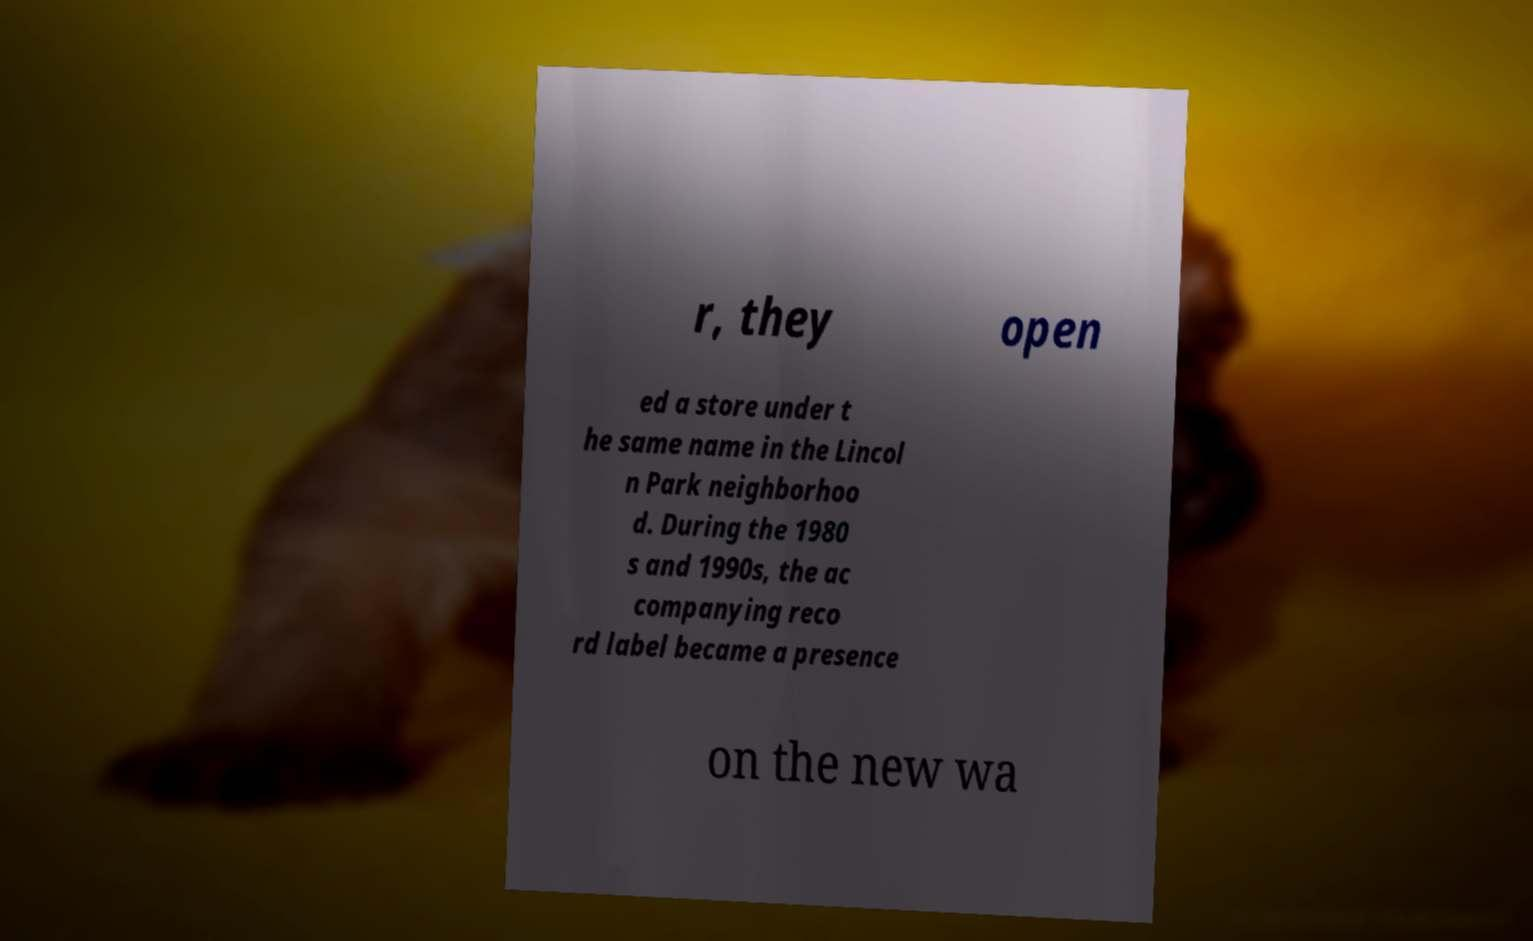There's text embedded in this image that I need extracted. Can you transcribe it verbatim? r, they open ed a store under t he same name in the Lincol n Park neighborhoo d. During the 1980 s and 1990s, the ac companying reco rd label became a presence on the new wa 